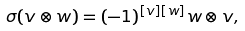Convert formula to latex. <formula><loc_0><loc_0><loc_500><loc_500>\sigma ( v \otimes w ) = ( - 1 ) ^ { [ v ] [ w ] } w \otimes v ,</formula> 